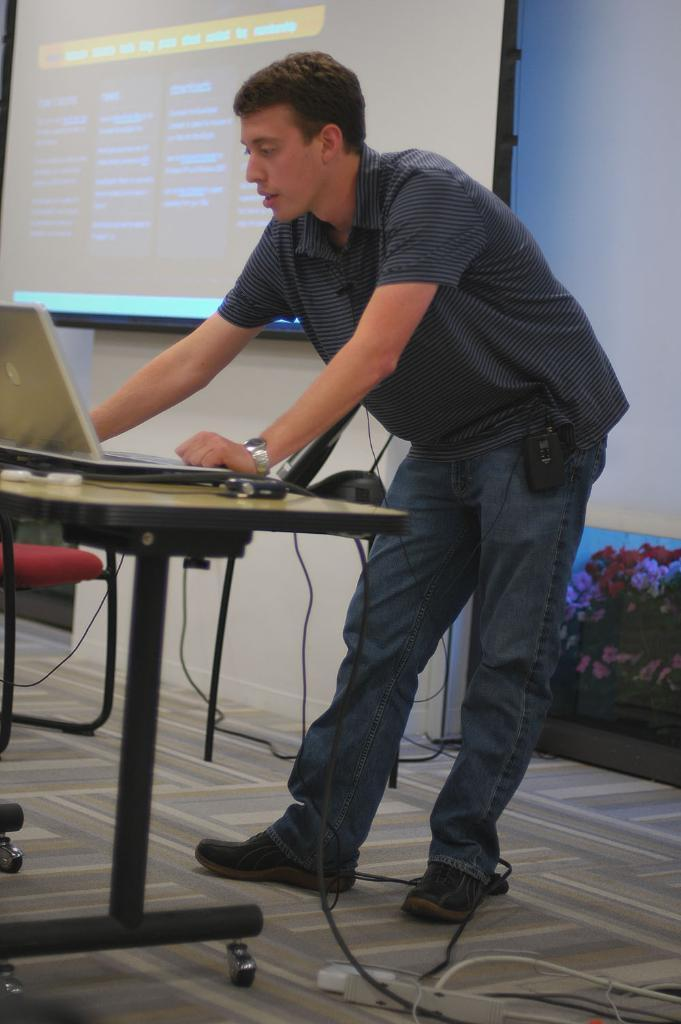What is the main subject in the image? There is a man standing in the image. What object can be seen near the man? There is a table in the image. What electronic device is on the table? A laptop is present on the table. What is used for controlling the laptop? A mouse is on the table. What is visible on the laptop? There is a screen visible in the image. What type of toy can be seen swimming in the image? There is no toy or swimming activity depicted in the image. 